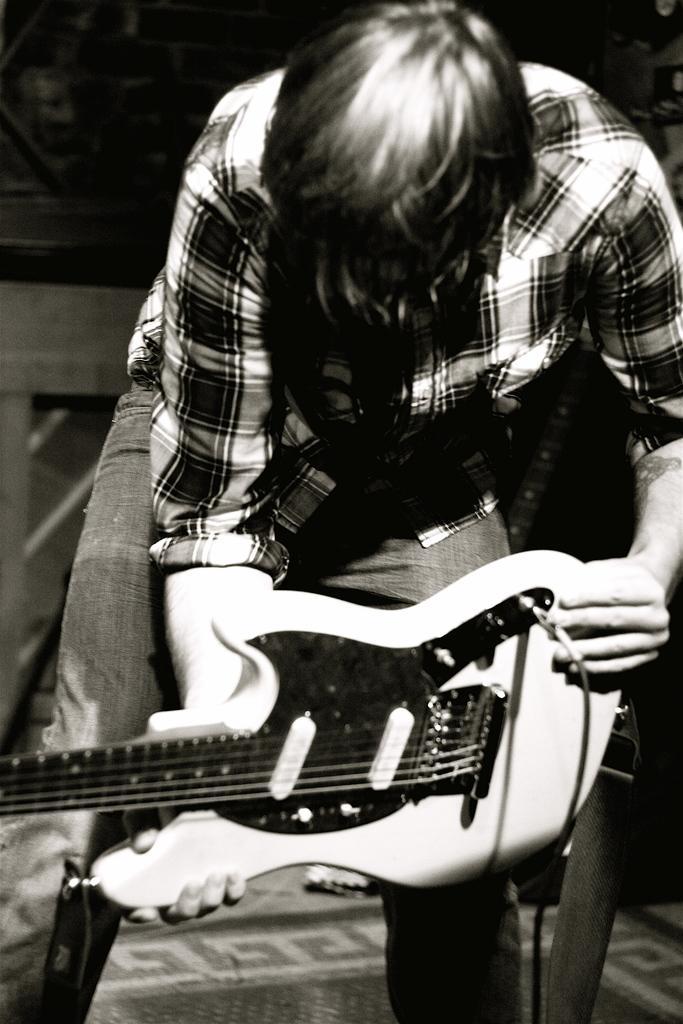Please provide a concise description of this image. In this picture we can see man standing and holding guitar in his hand and in background it is dark. 